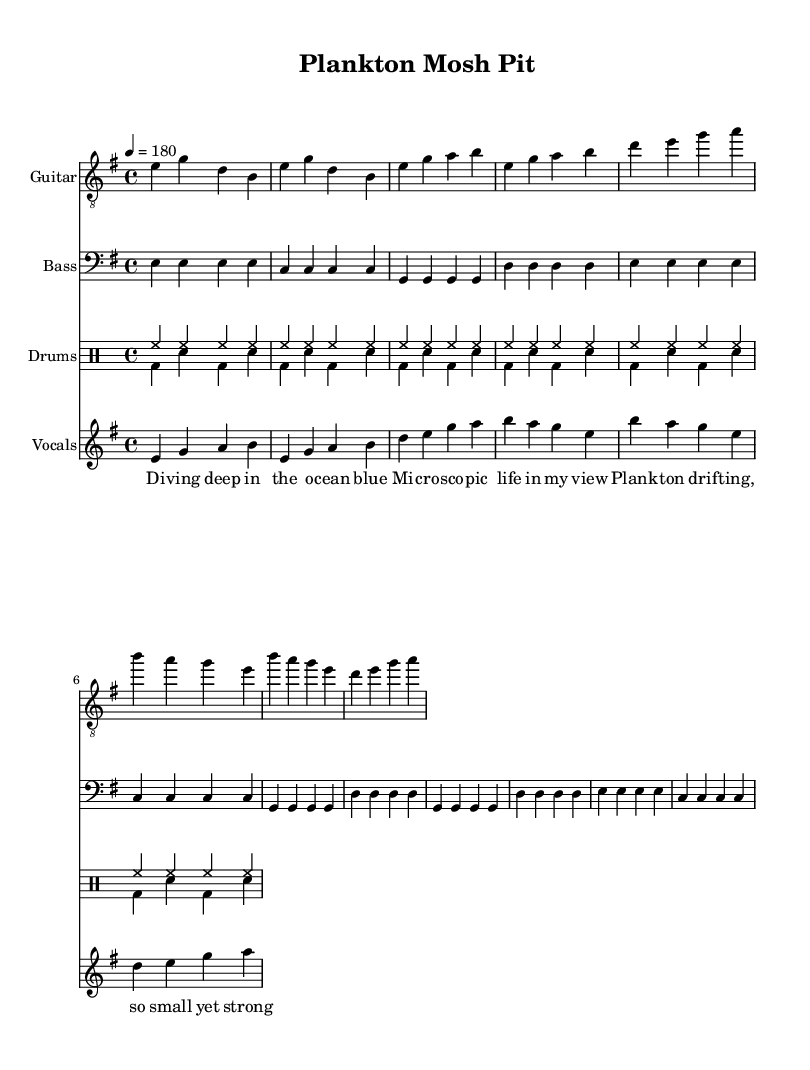What is the key signature of this music? The key signature is indicated by the key at the beginning of the score, which shows one sharp on the staff. This indicates that the music is in E minor, which has one sharp (F#).
Answer: E minor What is the time signature of this music? The time signature is displayed at the beginning of the score, under the key signature. It shows a "4/4" which means there are four beats in each measure and the quarter note receives one beat.
Answer: 4/4 What is the tempo marking for this piece? The tempo marking is located at the beginning of the score, indicating how fast the piece should be played. It shows "4 = 180", meaning the quarter note should be played at 180 beats per minute.
Answer: 180 How many verses are there in the lyrics? To determine the number of verses, I count the distinct sections of lyrics provided. The lyrics are broken down into a verse and a chorus, which shows there is one verse.
Answer: 1 What is the name of the song? The title of the sheet music is found at the top of the score, clearly labeled. The title listed is "Plankton Mosh Pit," which indicates the name of the song.
Answer: Plankton Mosh Pit In what style are the lyrics written? The song features lyrics that are rhythmically structured to match the music, indicating a punk style characterized by simplicity and energy. The focus is on marine life and celebrates diversity, common themes in punk anthems.
Answer: Punk 